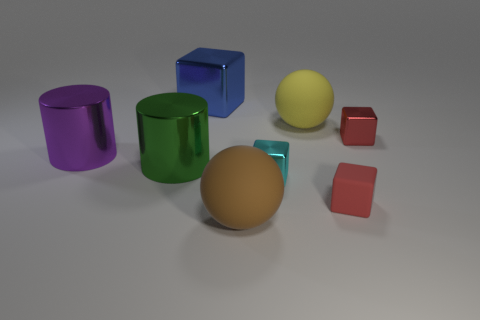There is a cyan thing that is the same shape as the small red metallic thing; what is its size?
Provide a short and direct response. Small. Is the material of the ball in front of the large yellow matte sphere the same as the yellow ball?
Give a very brief answer. Yes. What is the size of the brown rubber thing?
Your response must be concise. Large. There is a small thing that is the same color as the small matte block; what material is it?
Provide a short and direct response. Metal. What number of big shiny cylinders have the same color as the small matte cube?
Ensure brevity in your answer.  0. Do the blue object and the cyan metal thing have the same size?
Offer a very short reply. No. How big is the brown ball in front of the big matte thing that is right of the big brown sphere?
Give a very brief answer. Large. Do the matte block and the tiny metallic cube behind the purple cylinder have the same color?
Ensure brevity in your answer.  Yes. There is a rubber ball in front of the large purple shiny object; what size is it?
Keep it short and to the point. Large. Are there any small matte blocks to the right of the small metal object in front of the big purple cylinder?
Make the answer very short. Yes. 